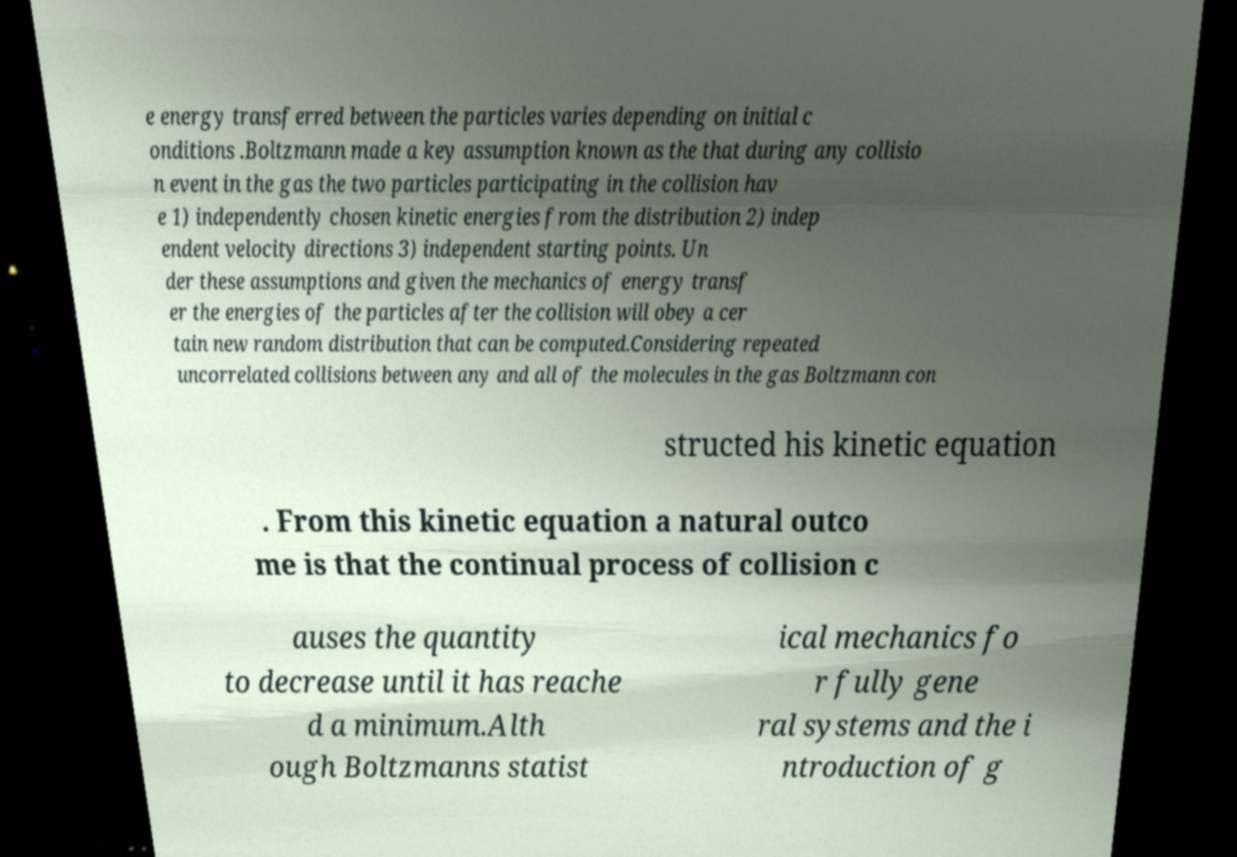Please read and relay the text visible in this image. What does it say? e energy transferred between the particles varies depending on initial c onditions .Boltzmann made a key assumption known as the that during any collisio n event in the gas the two particles participating in the collision hav e 1) independently chosen kinetic energies from the distribution 2) indep endent velocity directions 3) independent starting points. Un der these assumptions and given the mechanics of energy transf er the energies of the particles after the collision will obey a cer tain new random distribution that can be computed.Considering repeated uncorrelated collisions between any and all of the molecules in the gas Boltzmann con structed his kinetic equation . From this kinetic equation a natural outco me is that the continual process of collision c auses the quantity to decrease until it has reache d a minimum.Alth ough Boltzmanns statist ical mechanics fo r fully gene ral systems and the i ntroduction of g 